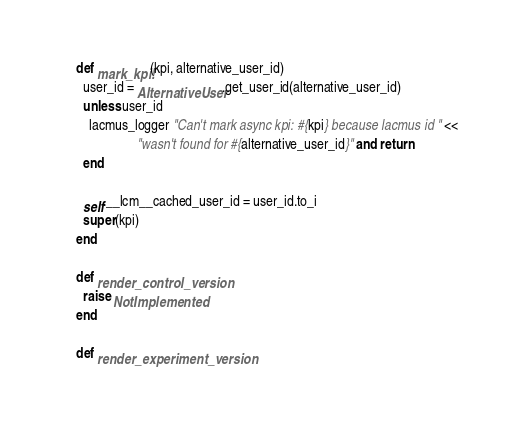Convert code to text. <code><loc_0><loc_0><loc_500><loc_500><_Ruby_>
    def mark_kpi!(kpi, alternative_user_id)
      user_id = AlternativeUser.get_user_id(alternative_user_id)
      unless user_id
        lacmus_logger "Can't mark async kpi: #{kpi} because lacmus id " <<
                      "wasn't found for #{alternative_user_id}" and return
      end

      self.__lcm__cached_user_id = user_id.to_i
      super(kpi)
    end

    def render_control_version
      raise NotImplemented
    end

    def render_experiment_version</code> 